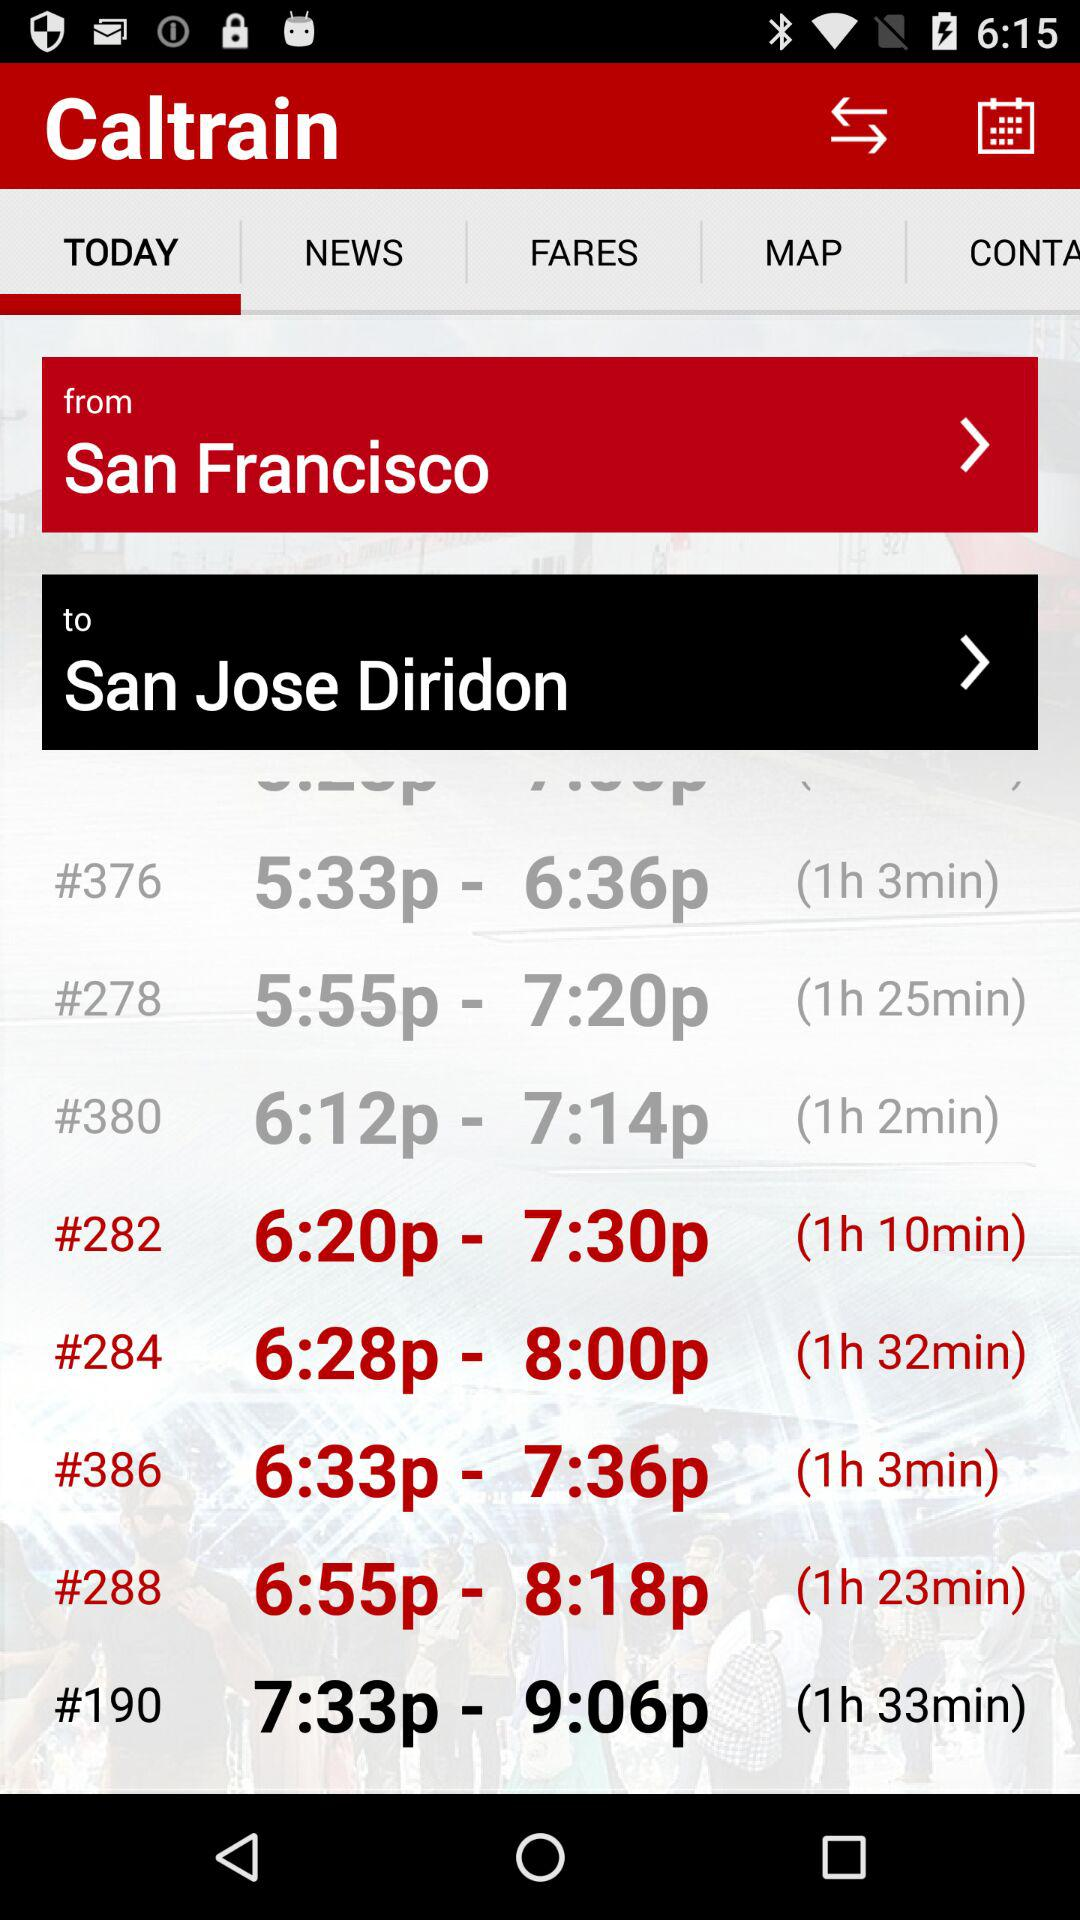What is the timing for the train with route number 284? The timing is from 6:28 p.m. to 8:00 p.m. 